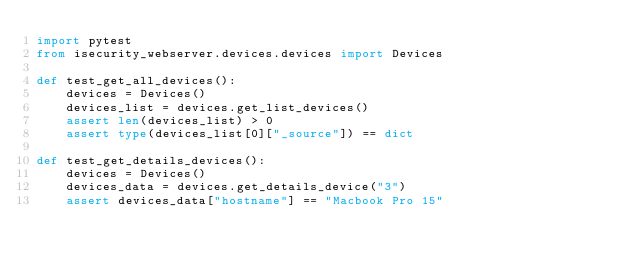Convert code to text. <code><loc_0><loc_0><loc_500><loc_500><_Python_>import pytest
from isecurity_webserver.devices.devices import Devices

def test_get_all_devices():
    devices = Devices()
    devices_list = devices.get_list_devices()
    assert len(devices_list) > 0
    assert type(devices_list[0]["_source"]) == dict

def test_get_details_devices():
    devices = Devices()
    devices_data = devices.get_details_device("3")
    assert devices_data["hostname"] == "Macbook Pro 15"
</code> 